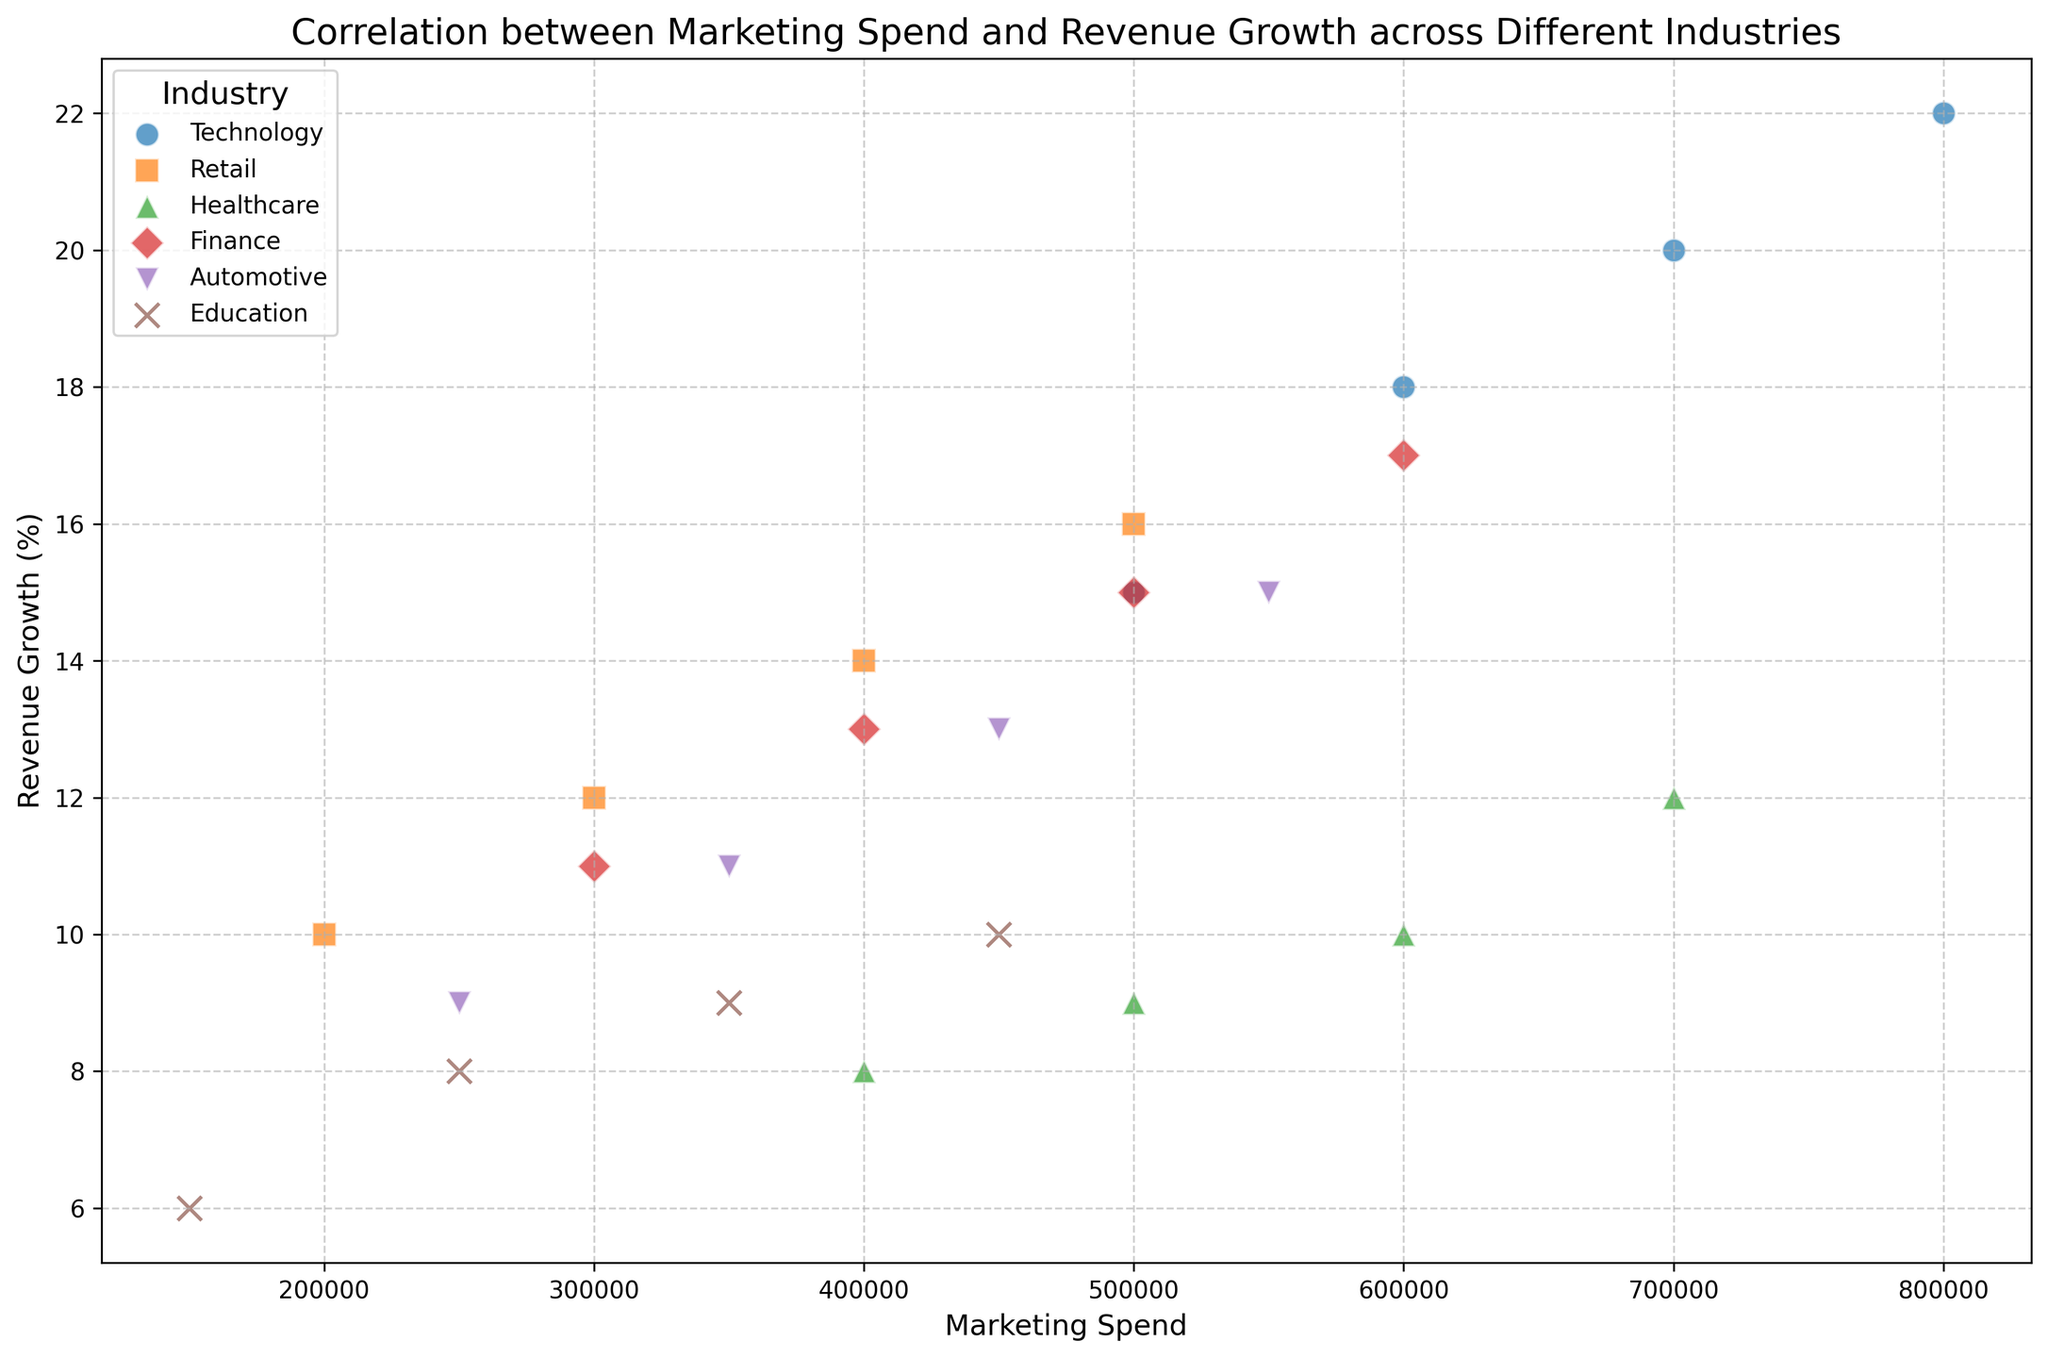What's the industry with the highest revenue growth for a marketing spend of $600,000? Look for the data points on the scatter plot where the x-axis value is $600,000. The revenue growth for different industries at this marketing spend is the y-axis value. The highest y-value at $600,000 spend is for Technology.
Answer: Technology How does the revenue growth compare between healthcare and finance industries for a marketing spend of $500,000? Identify the data points corresponding to a marketing spend of $500,000 for both Healthcare and Finance. Healthcare has a revenue growth value of 9%, while Finance has a value of 15%. Compare these two values.
Answer: Finance has higher revenue growth What's the difference in revenue growth between the industry with the highest and lowest growth for a marketing spend of $450,000? Find all data points where the marketing spend is $450,000. The highest revenue growth at this point is in the Finance industry (17%). The lowest growth is in the Education industry (10%). Subtract the lowest value from the highest.
Answer: 7% If we average the revenue growth of the Automotive industry for all recorded spends, what is the result? Sum all revenue growth values for the Automotive industry (9 + 11 + 13 + 15). Divide the sum by the number of data points (4) to find the average.
Answer: 12% Which industry shows the biggest increase in revenue growth between the lowest and highest marketing spend presented? Calculate the difference between revenue growth at the highest and lowest marketing spend for each industry. Technology has the differences: 22% - 15%, Retail has 16% - 10%, Healthcare has 12% - 8%, Finance has 17% - 11%, Automotive has 15% - 9%, and Education has 10% - 6%. Compare these differences, the largest of which is in the Technology industry (7%).
Answer: Technology What color represents the Retail industry on the scatter plot? Check the legend in the scatter plot which labels each industry with a distinct color. The Retail industry is marked in orange.
Answer: Orange Does any two industry overlap in their revenue growth for a marketing spend of $400,000? Find the data points where marketing spend is $400,000, and compare their y-values. Retail and Healthcare both have a revenue growth of 14% and 10% respectively. No overlap occurs since all values are distinct.
Answer: No overlap What is the pattern of revenue growth within the Technology industry as marketing spend increases? Track the data points for Technology along the x-axis from lowest to highest marketing spend. The pattern shows a steady increase in the revenue growth value consistently as marketing spend increases.
Answer: Steady increase What's the revenue growth range for the Retail industry according to the scatter plot? Look at all the data points representing the Retail industry and identify the lowest and highest revenue growth values. Retail ranges from 10% to 16%.
Answer: 10% to 16% Which industry has the broadest spread of marketing spend values? Observe the range of marketing spend data points along the x-axis for each industry. Technology has the widest spread, ranging from $500,000 to $800,000.
Answer: Technology 